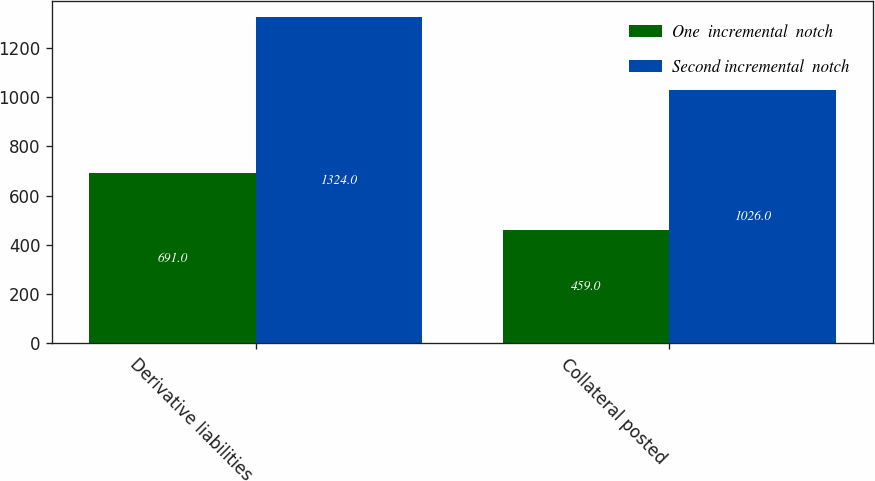Convert chart. <chart><loc_0><loc_0><loc_500><loc_500><stacked_bar_chart><ecel><fcel>Derivative liabilities<fcel>Collateral posted<nl><fcel>One  incremental  notch<fcel>691<fcel>459<nl><fcel>Second incremental  notch<fcel>1324<fcel>1026<nl></chart> 